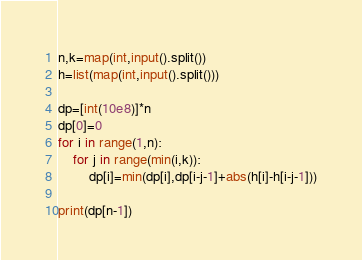<code> <loc_0><loc_0><loc_500><loc_500><_Python_>n,k=map(int,input().split())
h=list(map(int,input().split()))

dp=[int(10e8)]*n
dp[0]=0
for i in range(1,n):
    for j in range(min(i,k)):
        dp[i]=min(dp[i],dp[i-j-1]+abs(h[i]-h[i-j-1]))

print(dp[n-1])
</code> 